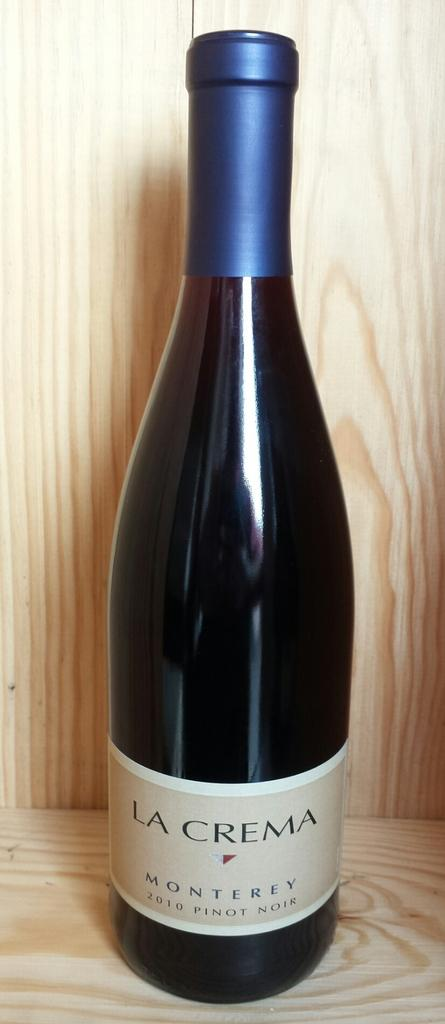<image>
Describe the image concisely. A bottle of La Crema Pinot Noir in a wooden cabinet. 